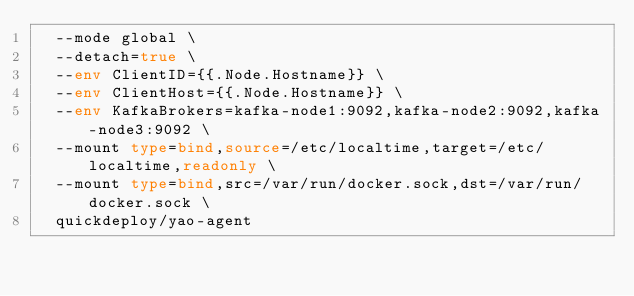<code> <loc_0><loc_0><loc_500><loc_500><_Bash_>	--mode global \
	--detach=true \
	--env ClientID={{.Node.Hostname}} \
	--env ClientHost={{.Node.Hostname}} \
	--env KafkaBrokers=kafka-node1:9092,kafka-node2:9092,kafka-node3:9092 \
	--mount type=bind,source=/etc/localtime,target=/etc/localtime,readonly \
	--mount type=bind,src=/var/run/docker.sock,dst=/var/run/docker.sock \
	quickdeploy/yao-agent
</code> 